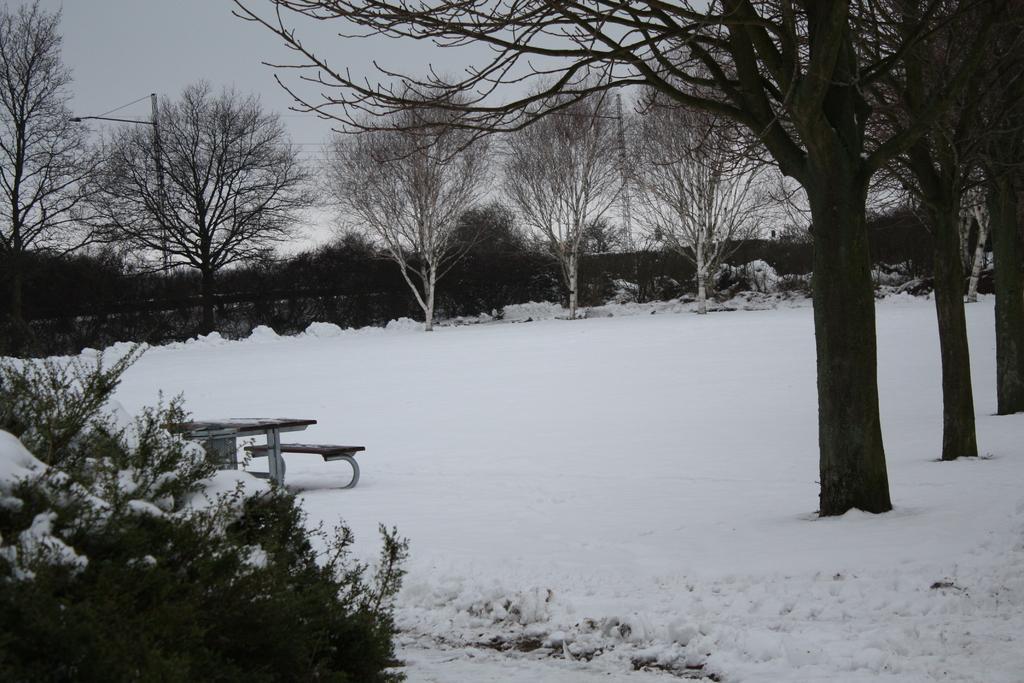Can you describe this image briefly? In this image there are trees. On the left there is a bench and we can see snow. In the background there is sky. There are poles. 